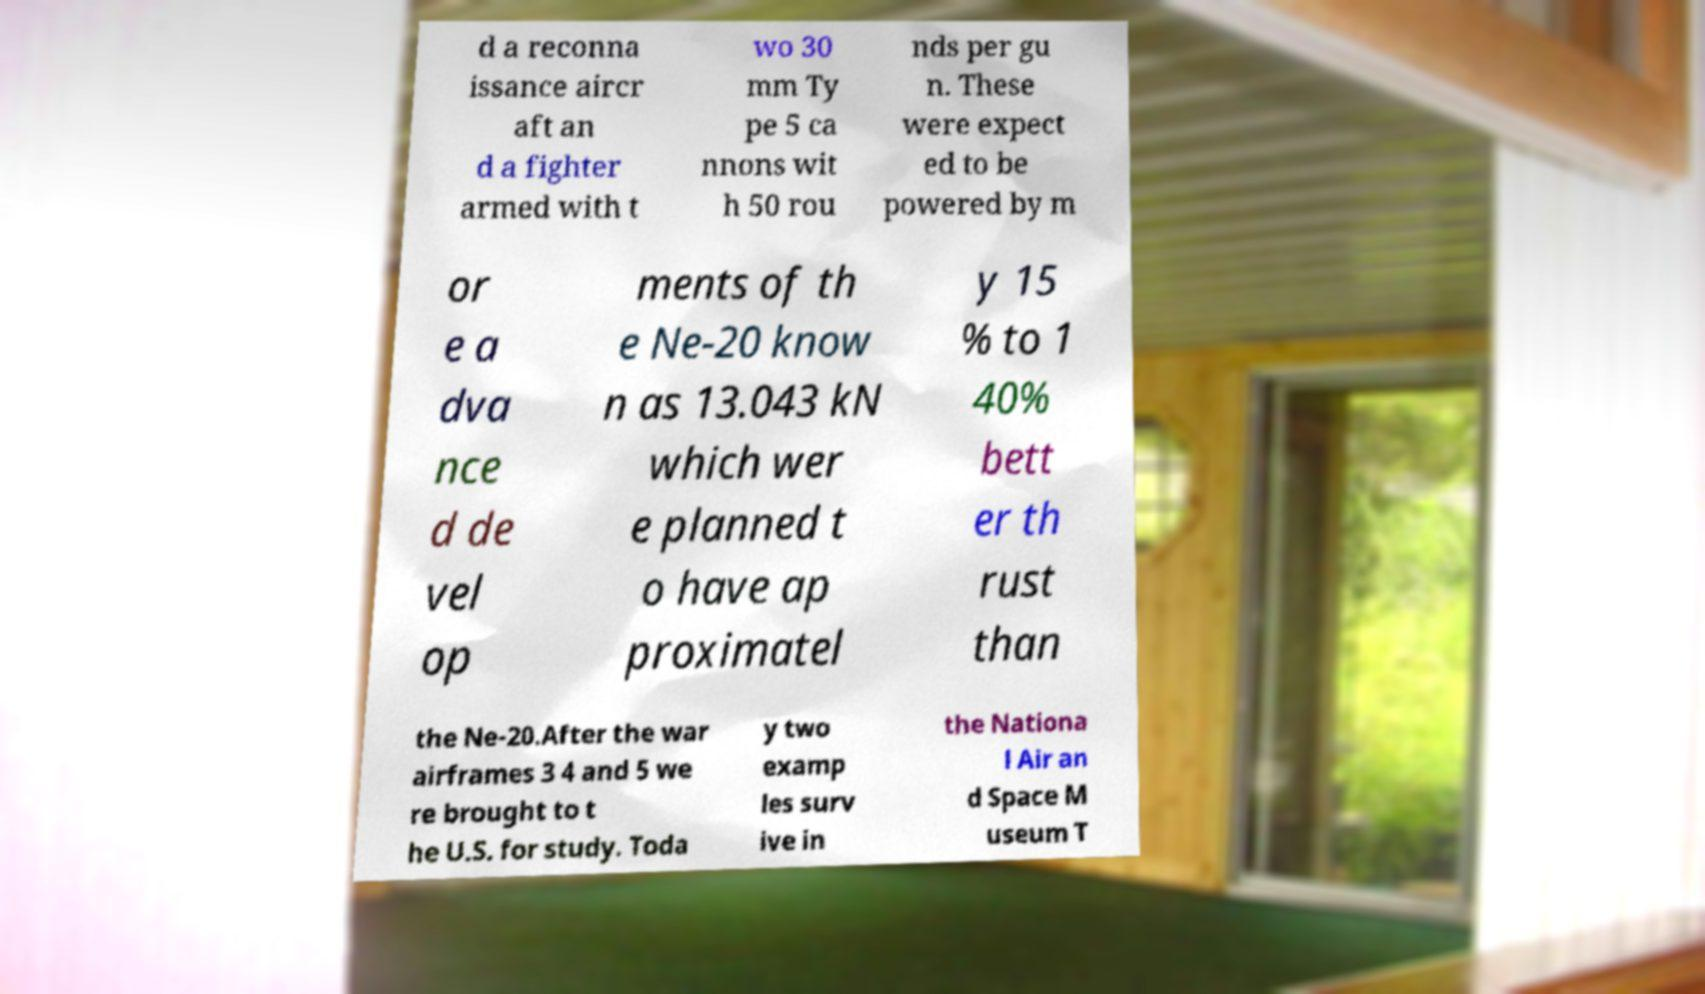Please read and relay the text visible in this image. What does it say? d a reconna issance aircr aft an d a fighter armed with t wo 30 mm Ty pe 5 ca nnons wit h 50 rou nds per gu n. These were expect ed to be powered by m or e a dva nce d de vel op ments of th e Ne-20 know n as 13.043 kN which wer e planned t o have ap proximatel y 15 % to 1 40% bett er th rust than the Ne-20.After the war airframes 3 4 and 5 we re brought to t he U.S. for study. Toda y two examp les surv ive in the Nationa l Air an d Space M useum T 